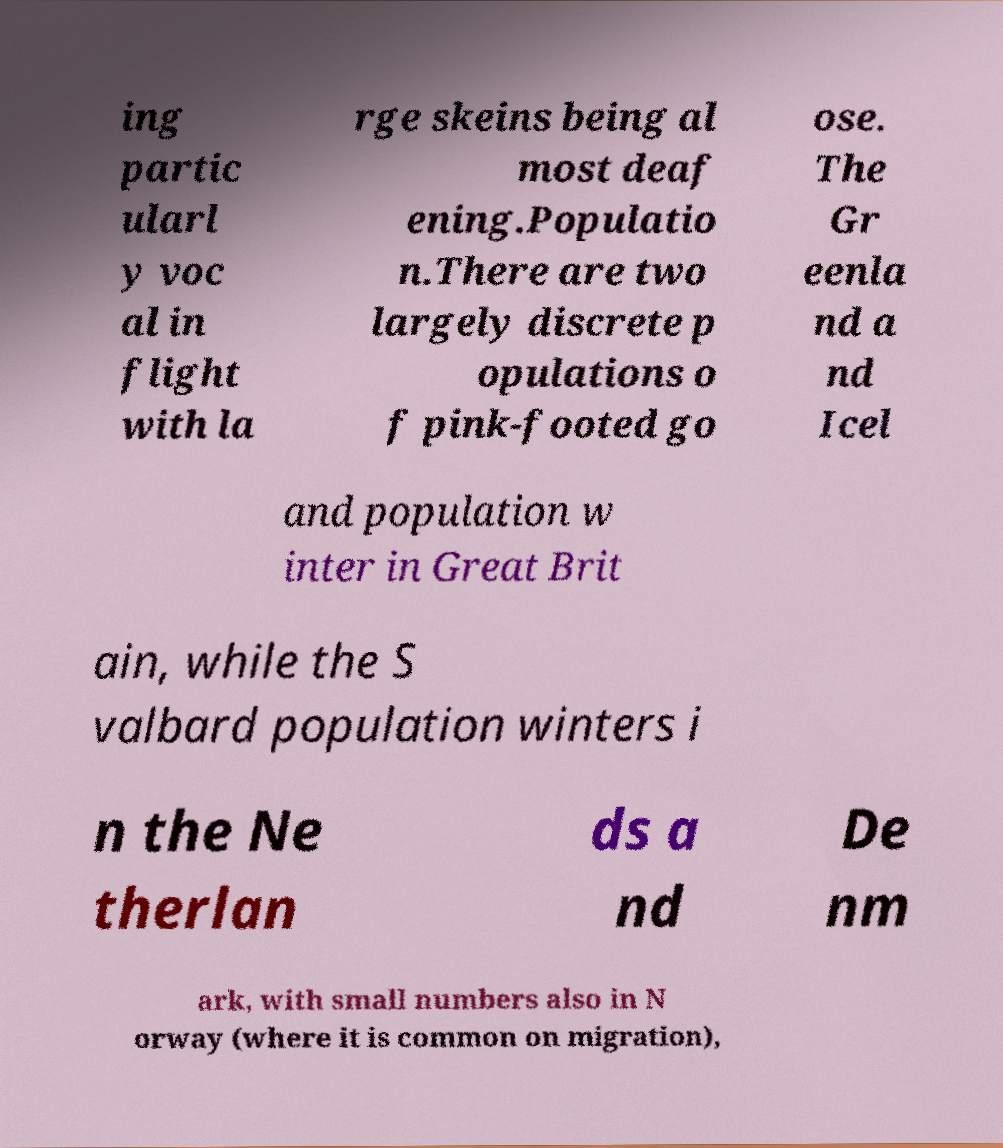Please identify and transcribe the text found in this image. ing partic ularl y voc al in flight with la rge skeins being al most deaf ening.Populatio n.There are two largely discrete p opulations o f pink-footed go ose. The Gr eenla nd a nd Icel and population w inter in Great Brit ain, while the S valbard population winters i n the Ne therlan ds a nd De nm ark, with small numbers also in N orway (where it is common on migration), 